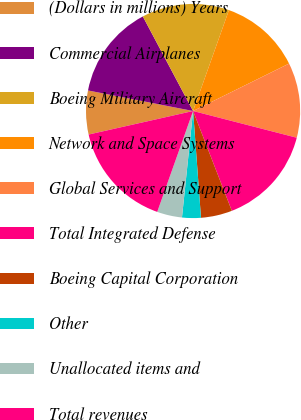Convert chart to OTSL. <chart><loc_0><loc_0><loc_500><loc_500><pie_chart><fcel>(Dollars in millions) Years<fcel>Commercial Airplanes<fcel>Boeing Military Aircraft<fcel>Network and Space Systems<fcel>Global Services and Support<fcel>Total Integrated Defense<fcel>Boeing Capital Corporation<fcel>Other<fcel>Unallocated items and<fcel>Total revenues<nl><fcel>6.6%<fcel>14.15%<fcel>13.21%<fcel>12.26%<fcel>11.32%<fcel>15.09%<fcel>4.72%<fcel>2.83%<fcel>3.78%<fcel>16.04%<nl></chart> 